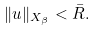Convert formula to latex. <formula><loc_0><loc_0><loc_500><loc_500>\| u \| _ { X _ { \beta } } < \bar { R } .</formula> 